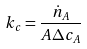Convert formula to latex. <formula><loc_0><loc_0><loc_500><loc_500>k _ { c } = \frac { \dot { n } _ { A } } { A \Delta c _ { A } }</formula> 